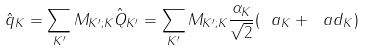<formula> <loc_0><loc_0><loc_500><loc_500>\hat { q } _ { K } = \sum _ { K ^ { \prime } } M _ { K ^ { \prime } ; K } \hat { Q } _ { K ^ { \prime } } = \sum _ { K ^ { \prime } } M _ { K ^ { \prime } ; K } \frac { \alpha _ { K } } { \sqrt { 2 } } ( \ a _ { K } + \ a d _ { K } )</formula> 